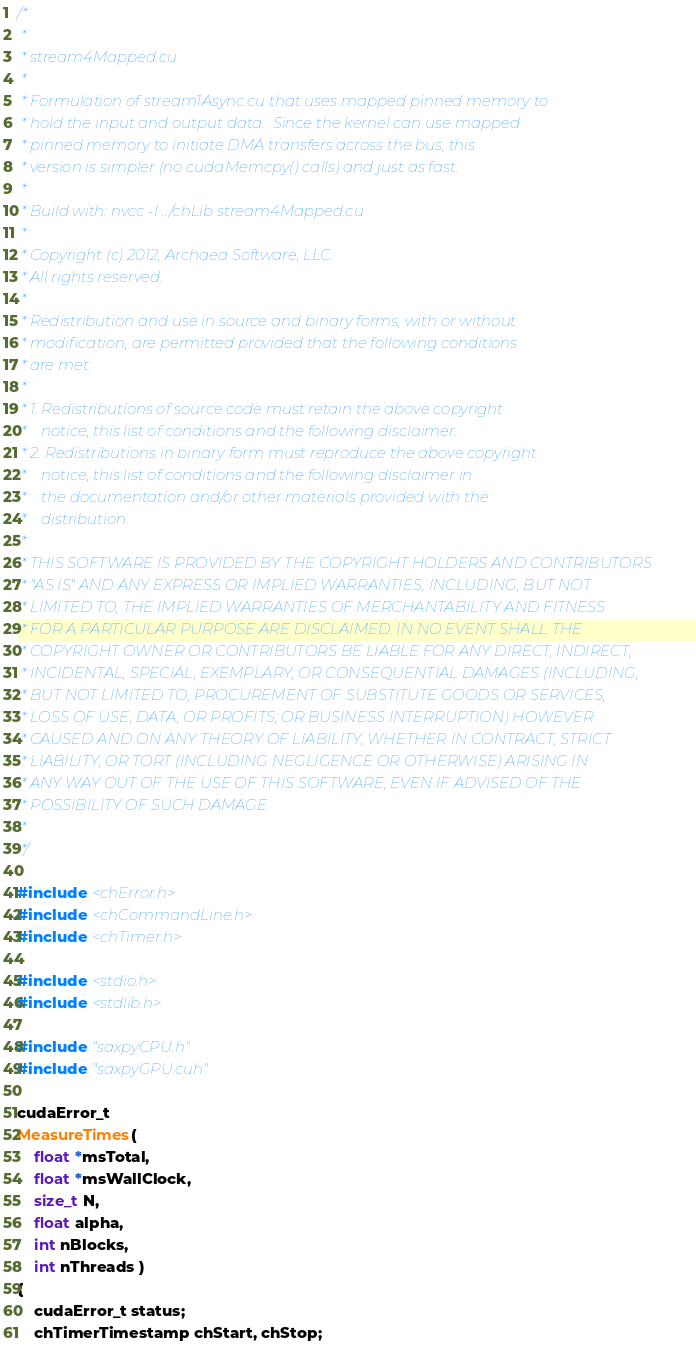Convert code to text. <code><loc_0><loc_0><loc_500><loc_500><_Cuda_>/*
 *
 * stream4Mapped.cu
 *
 * Formulation of stream1Async.cu that uses mapped pinned memory to
 * hold the input and output data.  Since the kernel can use mapped
 * pinned memory to initiate DMA transfers across the bus, this
 * version is simpler (no cudaMemcpy() calls) and just as fast.
 *
 * Build with: nvcc -I ../chLib stream4Mapped.cu
 *
 * Copyright (c) 2012, Archaea Software, LLC.
 * All rights reserved.
 *
 * Redistribution and use in source and binary forms, with or without
 * modification, are permitted provided that the following conditions 
 * are met: 
 *
 * 1. Redistributions of source code must retain the above copyright 
 *    notice, this list of conditions and the following disclaimer. 
 * 2. Redistributions in binary form must reproduce the above copyright 
 *    notice, this list of conditions and the following disclaimer in 
 *    the documentation and/or other materials provided with the 
 *    distribution. 
 *
 * THIS SOFTWARE IS PROVIDED BY THE COPYRIGHT HOLDERS AND CONTRIBUTORS 
 * "AS IS" AND ANY EXPRESS OR IMPLIED WARRANTIES, INCLUDING, BUT NOT 
 * LIMITED TO, THE IMPLIED WARRANTIES OF MERCHANTABILITY AND FITNESS 
 * FOR A PARTICULAR PURPOSE ARE DISCLAIMED. IN NO EVENT SHALL THE 
 * COPYRIGHT OWNER OR CONTRIBUTORS BE LIABLE FOR ANY DIRECT, INDIRECT, 
 * INCIDENTAL, SPECIAL, EXEMPLARY, OR CONSEQUENTIAL DAMAGES (INCLUDING, 
 * BUT NOT LIMITED TO, PROCUREMENT OF SUBSTITUTE GOODS OR SERVICES;
 * LOSS OF USE, DATA, OR PROFITS; OR BUSINESS INTERRUPTION) HOWEVER 
 * CAUSED AND ON ANY THEORY OF LIABILITY, WHETHER IN CONTRACT, STRICT 
 * LIABILITY, OR TORT (INCLUDING NEGLIGENCE OR OTHERWISE) ARISING IN 
 * ANY WAY OUT OF THE USE OF THIS SOFTWARE, EVEN IF ADVISED OF THE 
 * POSSIBILITY OF SUCH DAMAGE.
 *
 */

#include <chError.h>
#include <chCommandLine.h>
#include <chTimer.h>

#include <stdio.h>
#include <stdlib.h>

#include "saxpyCPU.h"
#include "saxpyGPU.cuh"

cudaError_t
MeasureTimes( 
    float *msTotal,
    float *msWallClock,
    size_t N, 
    float alpha,
    int nBlocks, 
    int nThreads )
{
    cudaError_t status;
    chTimerTimestamp chStart, chStop;</code> 